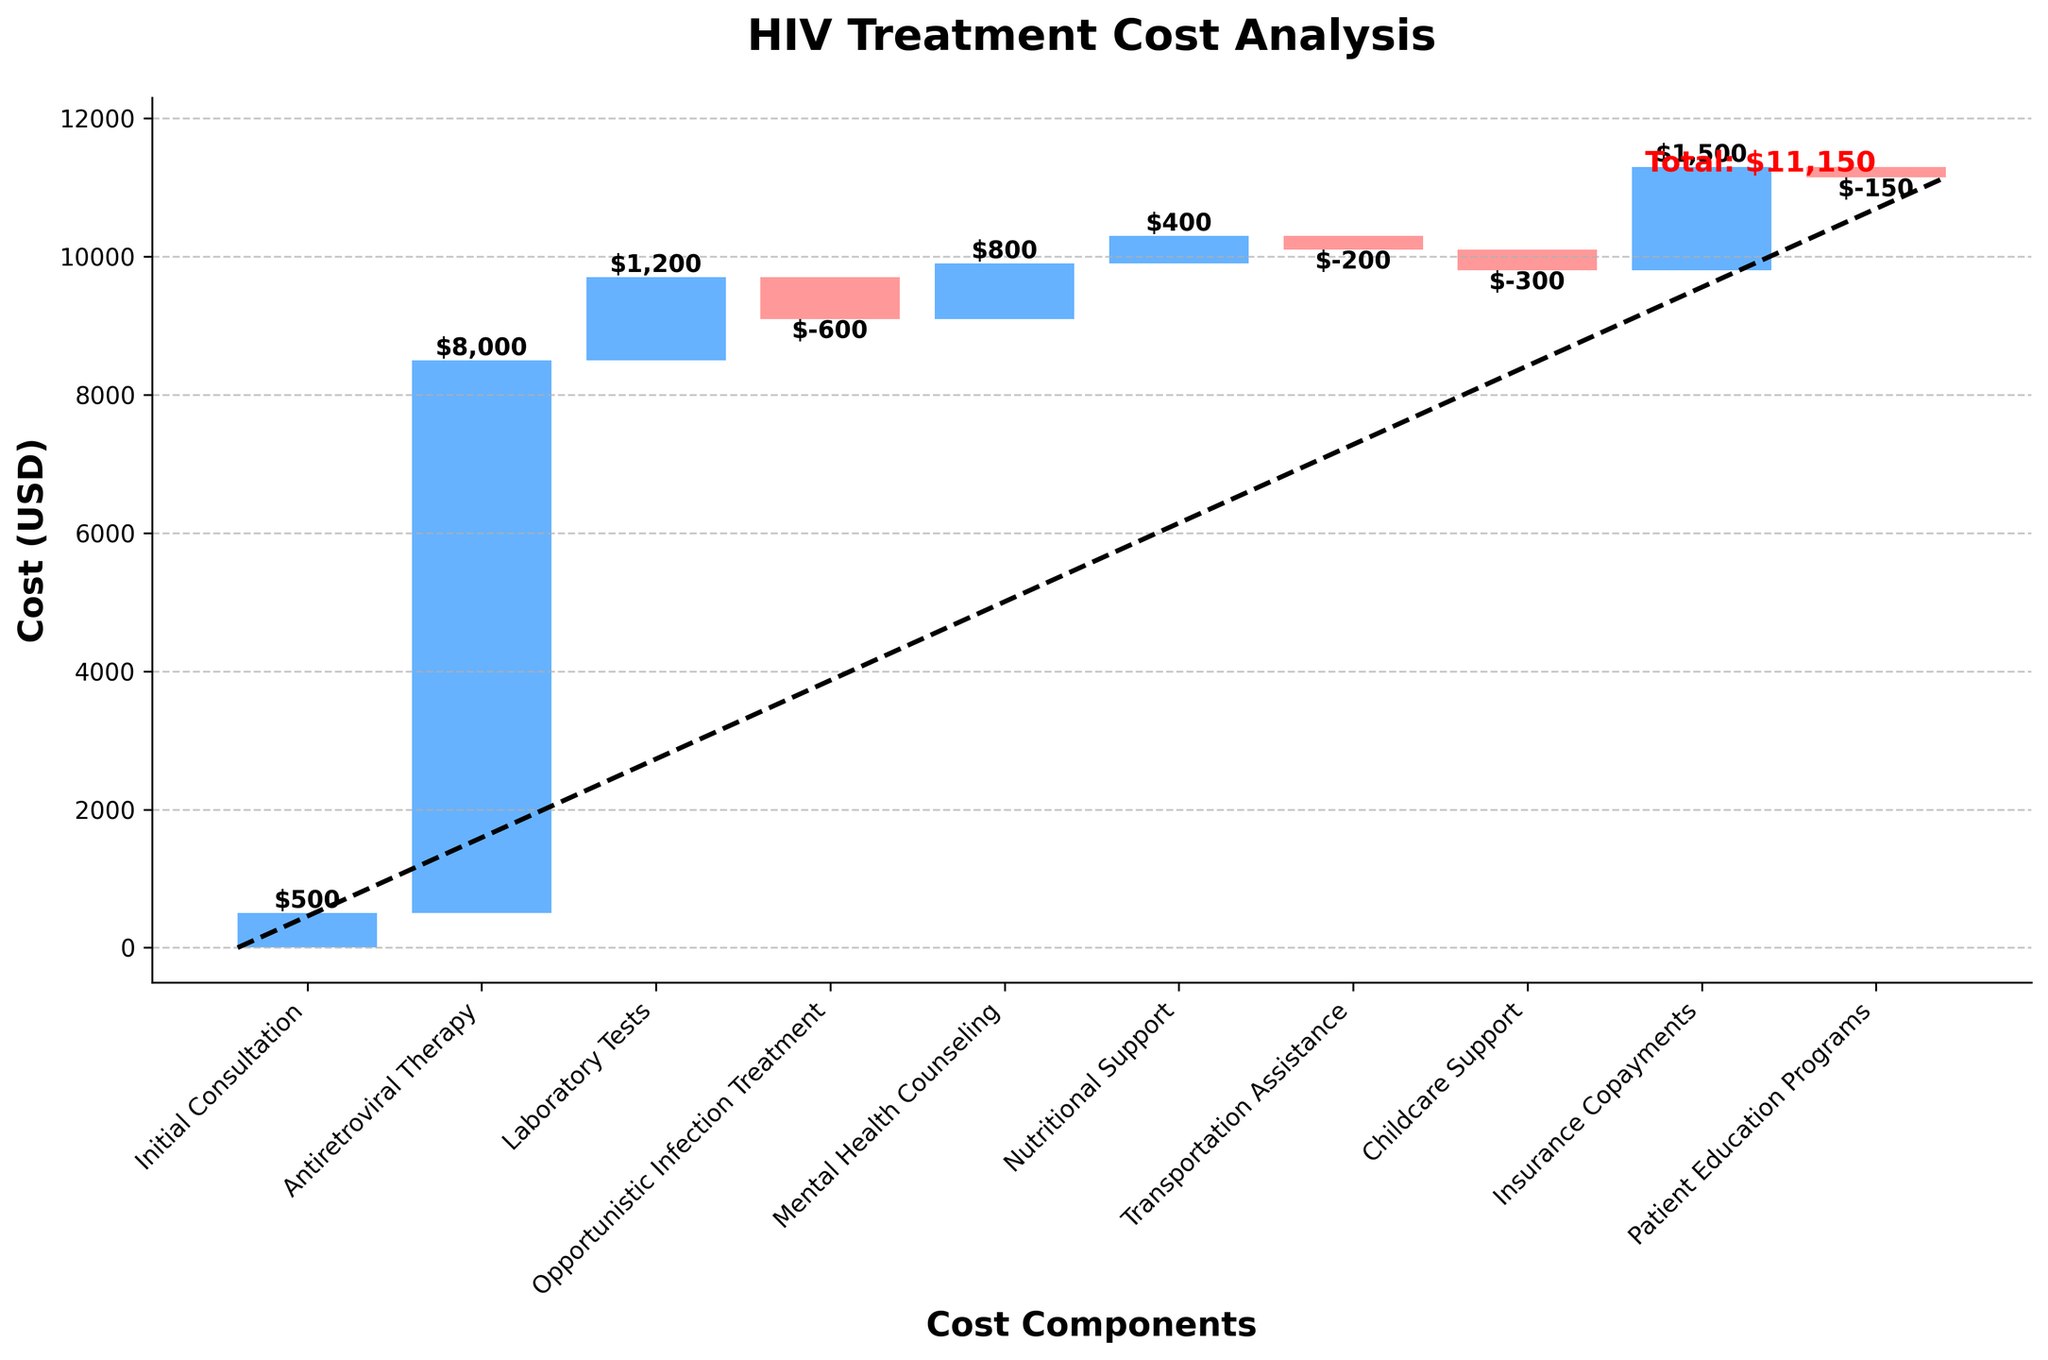What is the title of the chart? The title of the chart is displayed at the top and reads "HIV Treatment Cost Analysis".
Answer: HIV Treatment Cost Analysis How many categories of costs are there in the chart? Count the x-axis labels to determine the number of cost categories. There are 9 categories listed.
Answer: 9 Which cost category contributes the most to the total annual cost? Identify the category with the highest bar. "Antiretroviral Therapy" has the highest value of $8,000.
Answer: Antiretroviral Therapy What is the numerical value of the total annual cost? The total annual cost is indicated by a text label on the chart. The label reads "Total: $11,150".
Answer: $11,150 Which cost components result in a cost reduction? Look for bars with a different color, often used to indicate negative values. "Opportunistic Infection Treatment", "Transportation Assistance", "Childcare Support", and "Patient Education Programs" reduce costs.
Answer: Opportunistic Infection Treatment, Transportation Assistance, Childcare Support, Patient Education Programs What is the cost of Initial Consultation and Laboratory Tests combined? Sum the costs of Initial Consultation and Laboratory Tests, which are 500 and 1200 respectively. 500 + 1200 = 1700.
Answer: $1,700 By how much does Mental Health Counseling increase the total cost? Identify the value of the Mental Health Counseling bar. The bar indicates a cost of $800.
Answer: $800 Is the cost for Nutritional Support more or less than that for Patient Education Programs? Compare the heights of the respective bars. Nutritional Support costs $400, which is more than the -$150 for Patient Education Programs.
Answer: More How much does Insurance Copayments contribute to the total cost compared to Nutritional Support? Subtract the cost of Nutritional Support from the cost of Insurance Copayments. 1500 - 400 = 1100.
Answer: $1,100 What is the total reduction in cost provided by the categories resulting in cost reductions? Sum the negative contributions: -600 (Opportunistic Infection Treatment) - 200 (Transportation Assistance) - 300 (Childcare Support) - 150 (Patient Education Programs) = -1250.
Answer: $1,250 